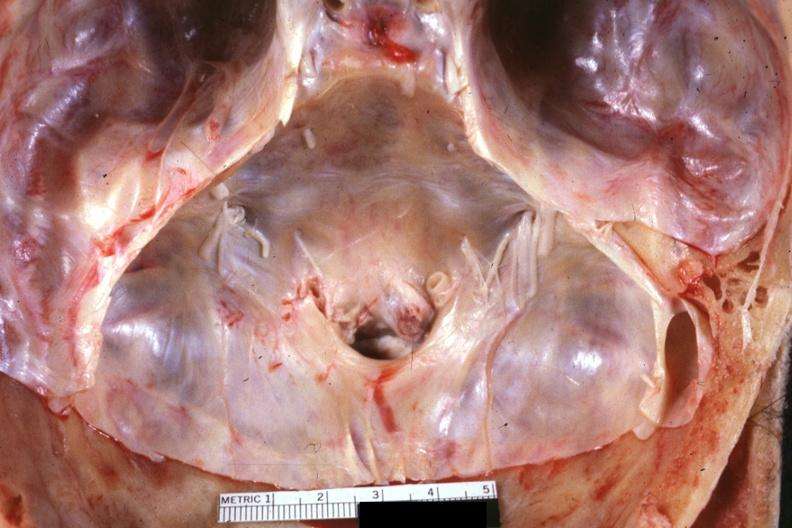what is present?
Answer the question using a single word or phrase. Bone 